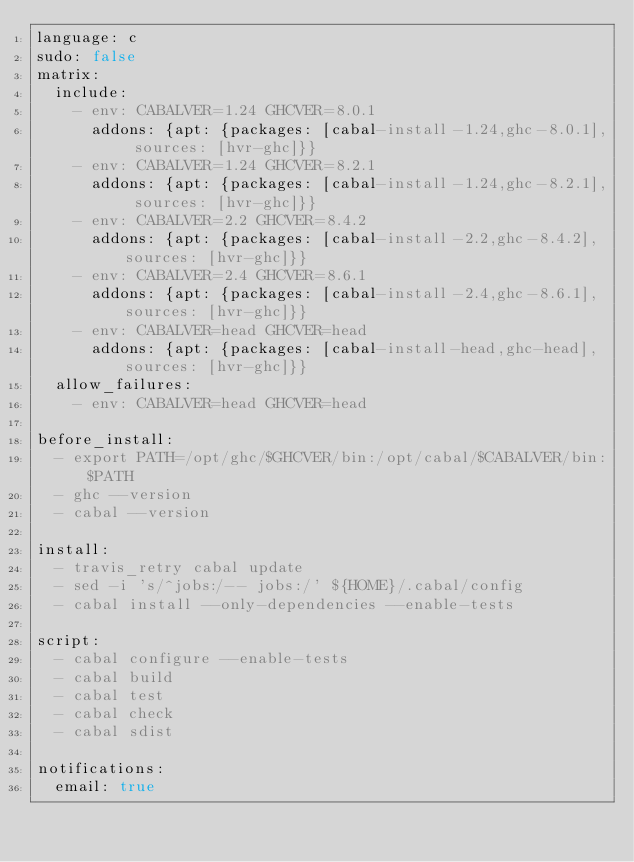<code> <loc_0><loc_0><loc_500><loc_500><_YAML_>language: c
sudo: false
matrix:
  include:
    - env: CABALVER=1.24 GHCVER=8.0.1
      addons: {apt: {packages: [cabal-install-1.24,ghc-8.0.1], sources: [hvr-ghc]}}
    - env: CABALVER=1.24 GHCVER=8.2.1
      addons: {apt: {packages: [cabal-install-1.24,ghc-8.2.1], sources: [hvr-ghc]}}
    - env: CABALVER=2.2 GHCVER=8.4.2
      addons: {apt: {packages: [cabal-install-2.2,ghc-8.4.2], sources: [hvr-ghc]}}
    - env: CABALVER=2.4 GHCVER=8.6.1
      addons: {apt: {packages: [cabal-install-2.4,ghc-8.6.1], sources: [hvr-ghc]}}
    - env: CABALVER=head GHCVER=head
      addons: {apt: {packages: [cabal-install-head,ghc-head], sources: [hvr-ghc]}}
  allow_failures:
    - env: CABALVER=head GHCVER=head

before_install:
  - export PATH=/opt/ghc/$GHCVER/bin:/opt/cabal/$CABALVER/bin:$PATH
  - ghc --version
  - cabal --version

install:
  - travis_retry cabal update
  - sed -i 's/^jobs:/-- jobs:/' ${HOME}/.cabal/config
  - cabal install --only-dependencies --enable-tests

script:
  - cabal configure --enable-tests
  - cabal build
  - cabal test
  - cabal check
  - cabal sdist

notifications:
  email: true
</code> 